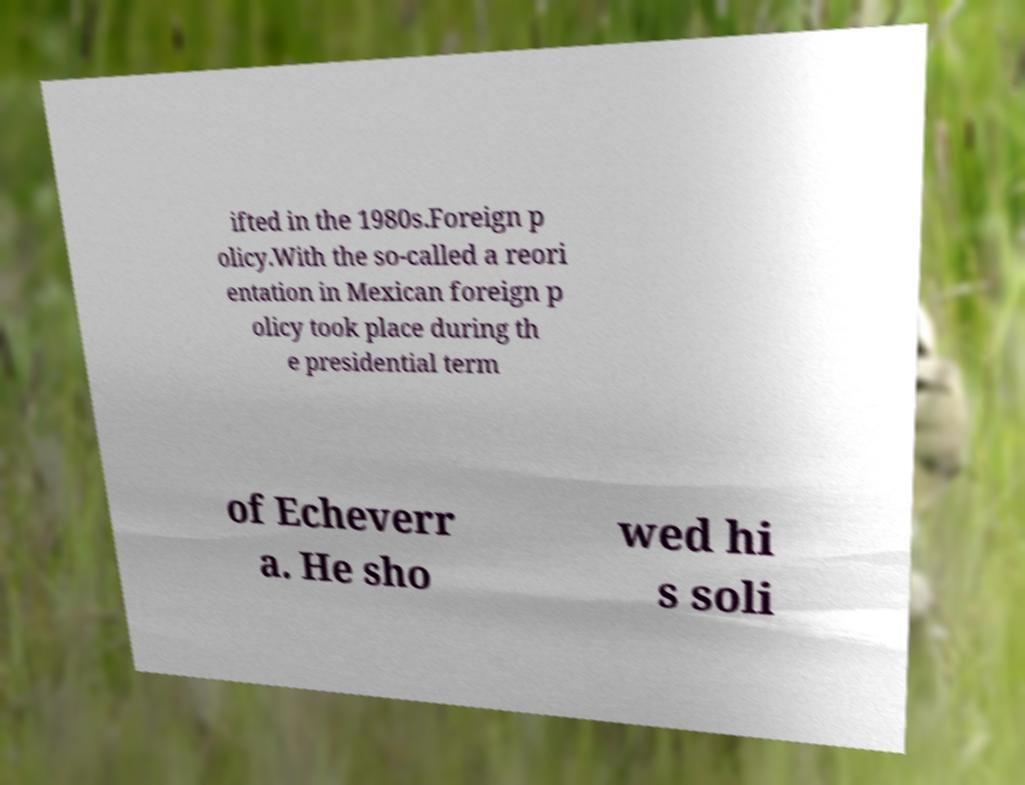Can you read and provide the text displayed in the image?This photo seems to have some interesting text. Can you extract and type it out for me? ifted in the 1980s.Foreign p olicy.With the so-called a reori entation in Mexican foreign p olicy took place during th e presidential term of Echeverr a. He sho wed hi s soli 